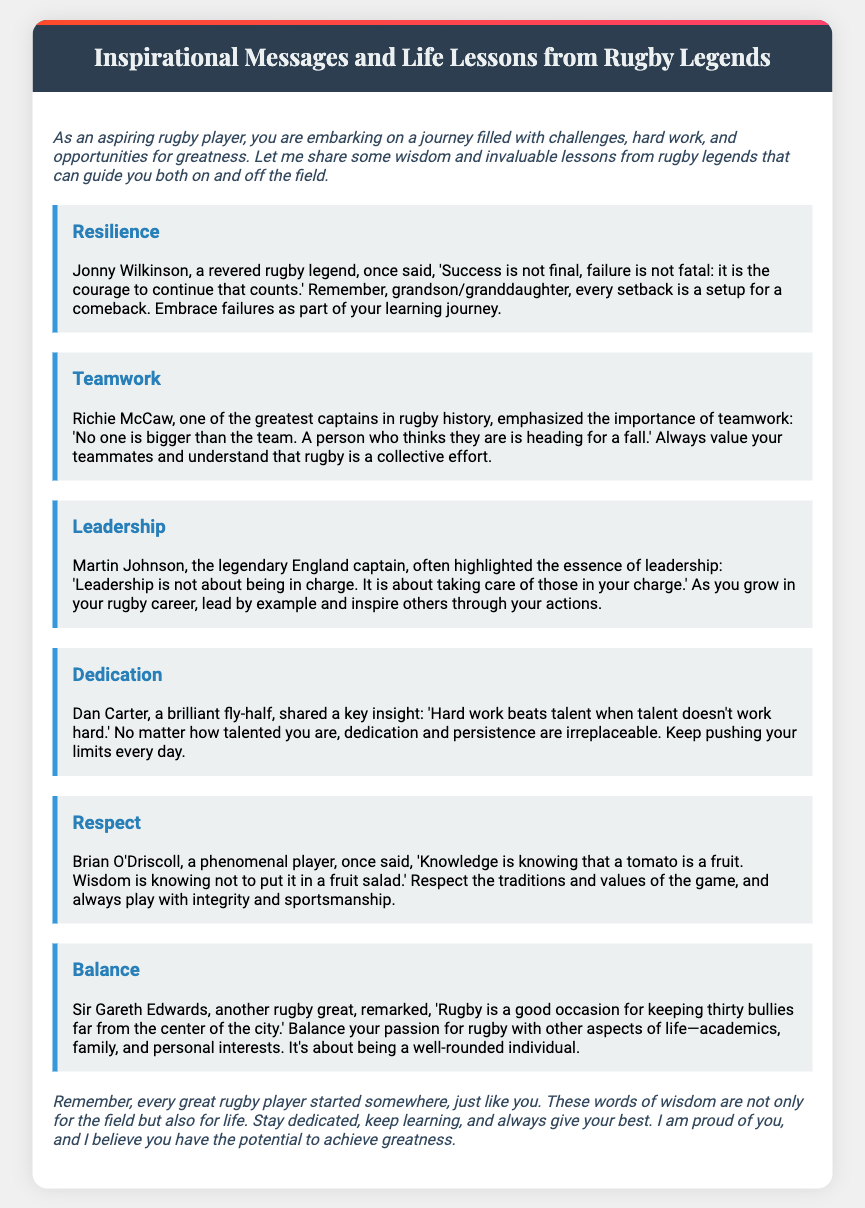What is the title of the document? The title of the document is found in the header section, which reads "Inspirational Messages and Life Lessons from Rugby Legends."
Answer: Inspirational Messages and Life Lessons from Rugby Legends Who emphasized the importance of teamwork? The person who emphasized teamwork is mentioned in the section dedicated to teamwork.
Answer: Richie McCaw What did Jonny Wilkinson say about success and failure? Jonny Wilkinson's quote about success and failure can be found in the resilience section.
Answer: "Success is not final, failure is not fatal: it is the courage to continue that counts." Which rugby legend highlighted the essence of leadership? The rugby legend that highlighted leadership is mentioned in the leadership section.
Answer: Martin Johnson What is one key insight shared by Dan Carter? Dan Carter's key insight is found in his dedicated message about dedication.
Answer: "Hard work beats talent when talent doesn't work hard." In which section is rugby respect mentioned? The respect for rugby is discussed in its own message section.
Answer: Respect What balance did Sir Gareth Edwards refer to in his quote? Sir Gareth Edwards referred to balancing rugby with other aspects of life.
Answer: Balance What is the overall message in the conclusion? The conclusion provides a message of encouragement for aspiring rugby players.
Answer: Stay dedicated, keep learning, and always give your best 